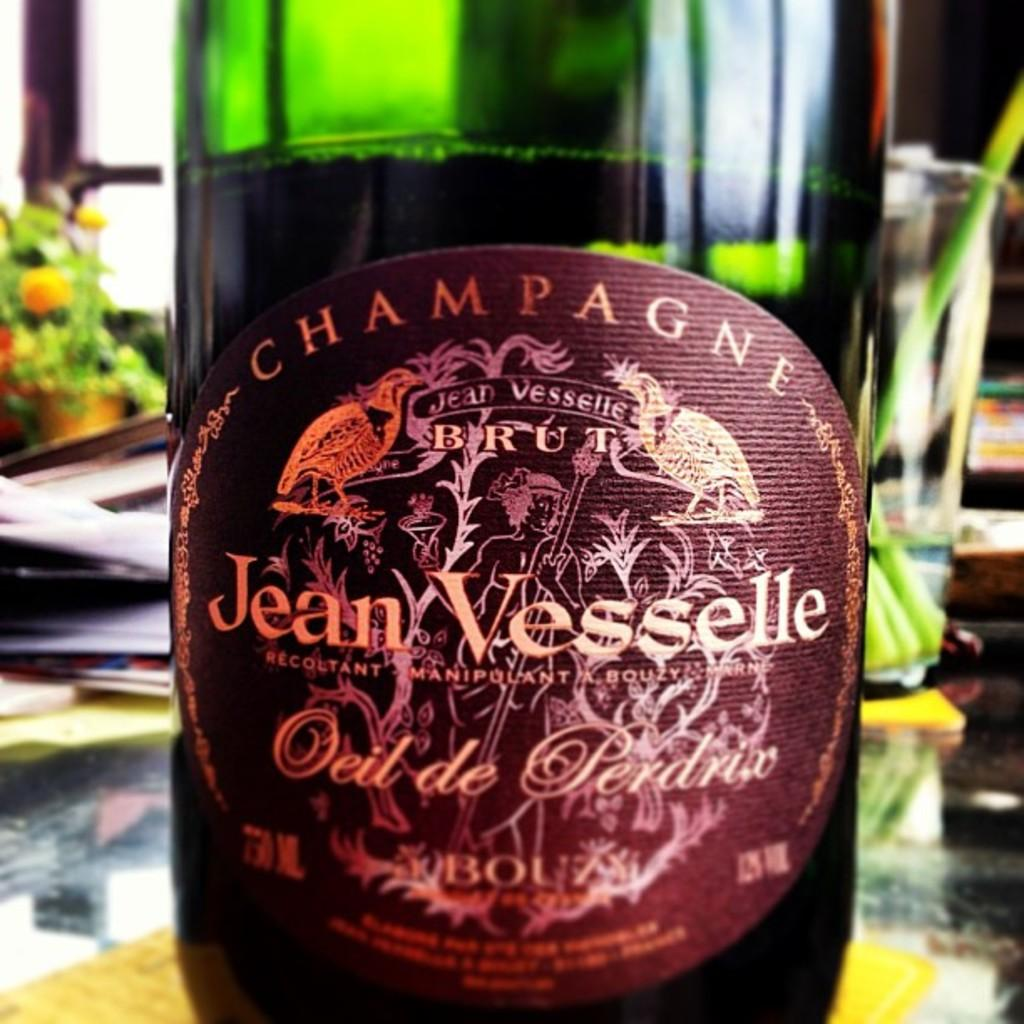Provide a one-sentence caption for the provided image. A bottle of champagne has Jean Vesselle on the label. 